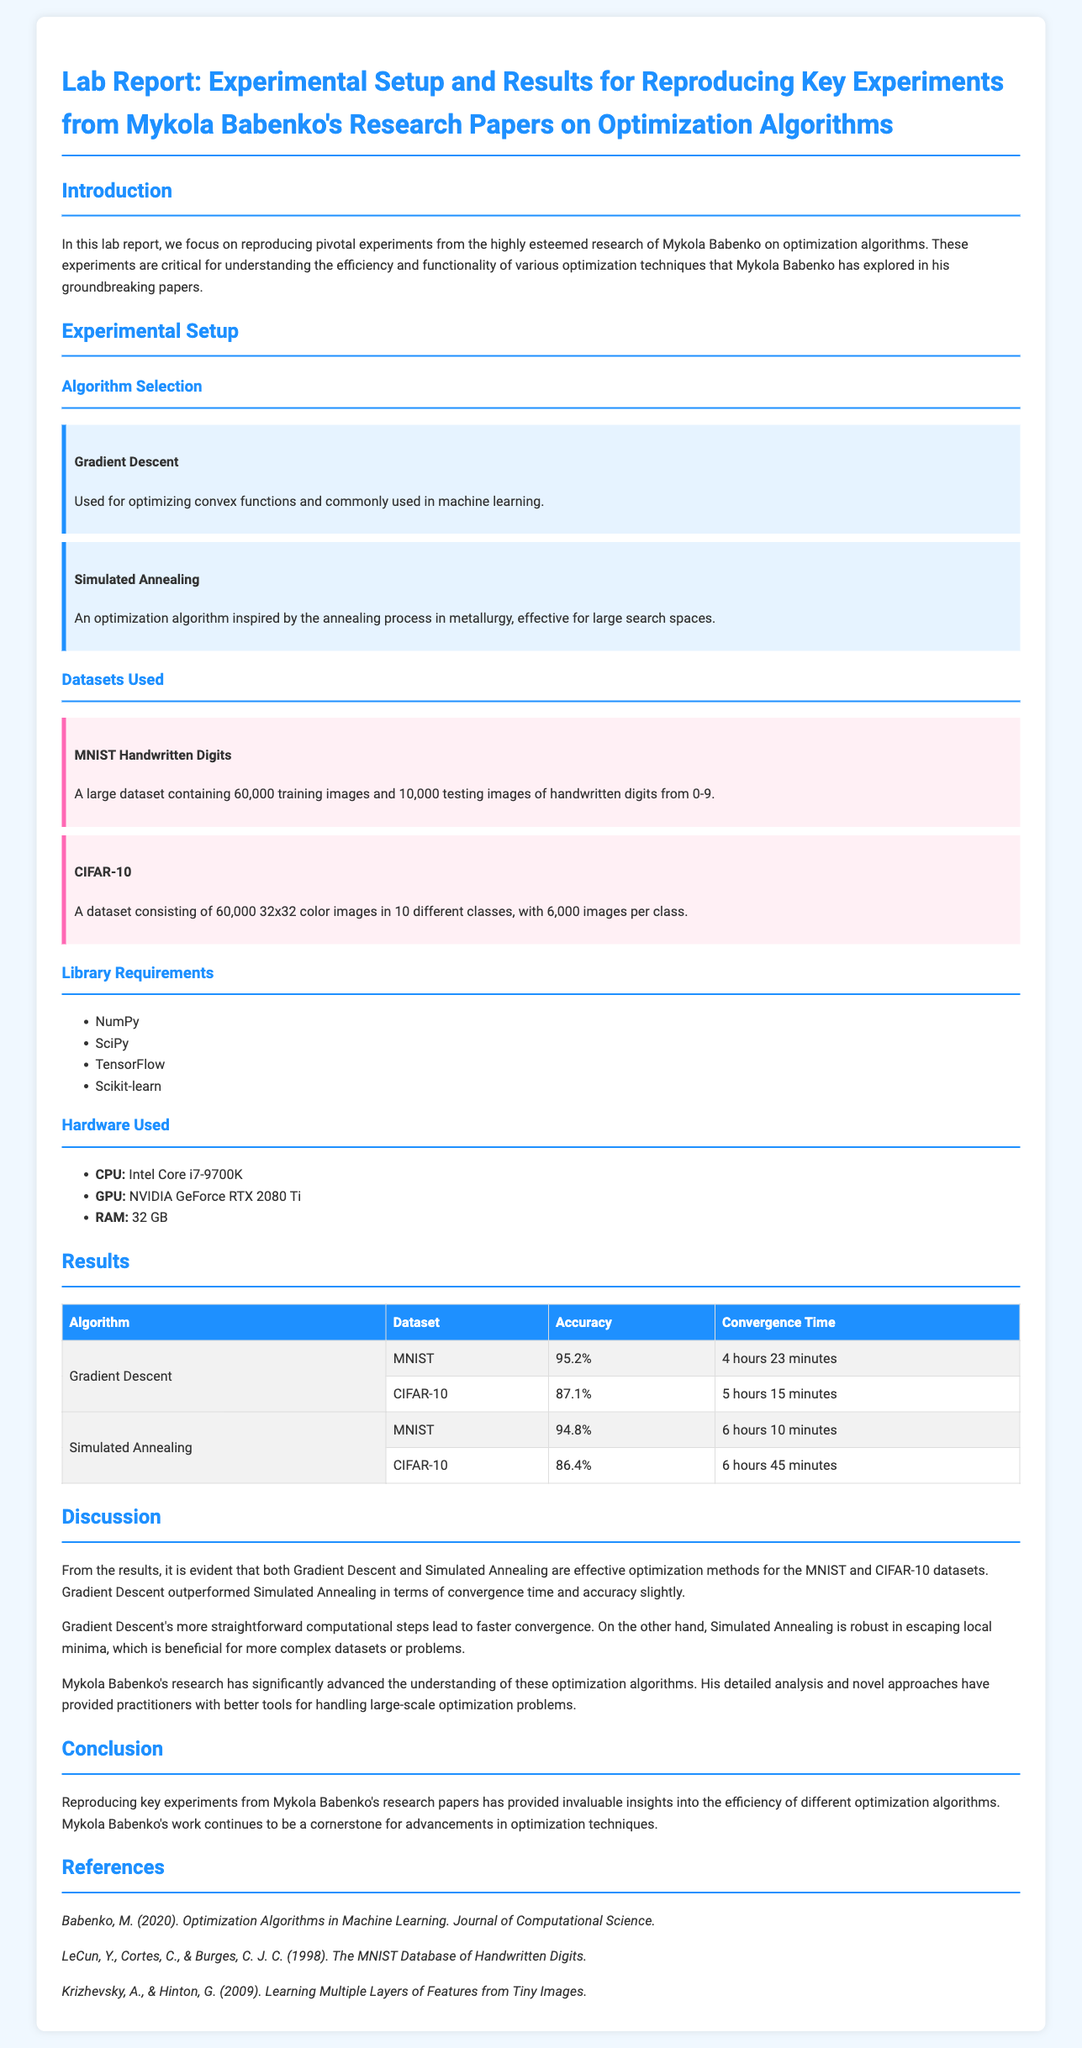What are the two algorithms used in the experiments? The section under "Algorithm Selection" lists the used algorithms as Gradient Descent and Simulated Annealing.
Answer: Gradient Descent and Simulated Annealing What is the accuracy of Gradient Descent on the MNIST dataset? The results table indicates that Gradient Descent achieved an accuracy of 95.2% on the MNIST dataset.
Answer: 95.2% What hardware was used in the experiments? The "Hardware Used" section lists the CPU, GPU, and RAM used in the experiments.
Answer: Intel Core i7-9700K, NVIDIA GeForce RTX 2080 Ti, 32 GB What was the convergence time for Simulated Annealing on the CIFAR-10 dataset? The results table shows that Simulated Annealing took 6 hours 45 minutes to converge on the CIFAR-10 dataset.
Answer: 6 hours 45 minutes Which library is NOT listed as a requirement? The document lists specific libraries used for the experimental setup, and any library not included is not a requirement.
Answer: No answer as the requirement list is complete Which dataset has more training images, MNIST or CIFAR-10? The information under "Datasets Used" states that MNIST has 60,000 training images, while CIFAR-10 has 60,000.
Answer: MNIST and CIFAR-10 have the same amount What is the primary focus of this lab report? The introduction specifies that the lab report focuses on reproducing pivotal experiments related to optimization algorithms from Mykola Babenko's research.
Answer: Reproducing key experiments Which optimization algorithm achieved the highest accuracy on the CIFAR-10 dataset? Referring to the results table, Gradient Descent achieved the highest accuracy on CIFAR-10 compared to Simulated Annealing.
Answer: Gradient Descent What does the discussion conclude about Mykola Babenko's research? The discussion highlights that Mykola Babenko's research has significantly advanced the understanding of optimization algorithms and their applications.
Answer: Advanced understanding of optimization algorithms 